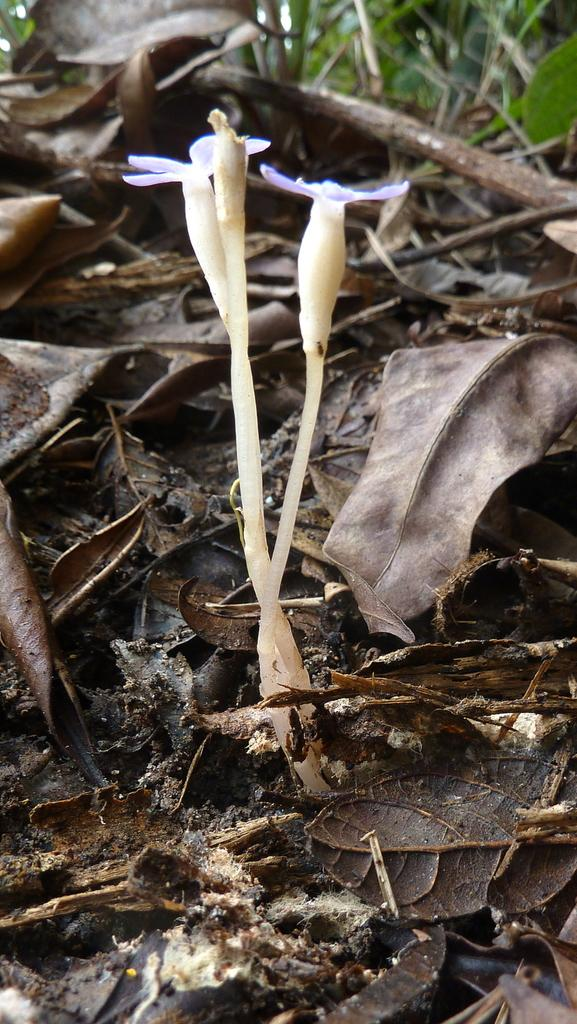What type of plants are in the image? There are plants with flowers in the image. What can be seen on the ground near the plants? Dry leaves are visible in the image. What parts of the plants are visible at the top of the image? Stems and green leaves are present at the top of the image. What type of soap is being used to play the guitar in the image? There is no soap or guitar present in the image; it features plants with flowers, dry leaves, and green leaves. 